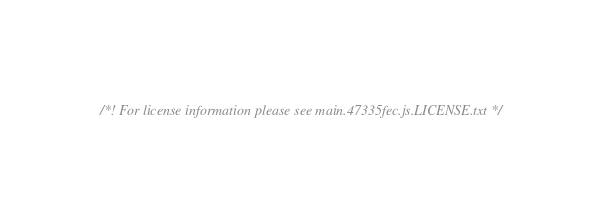Convert code to text. <code><loc_0><loc_0><loc_500><loc_500><_JavaScript_>/*! For license information please see main.47335fec.js.LICENSE.txt */</code> 